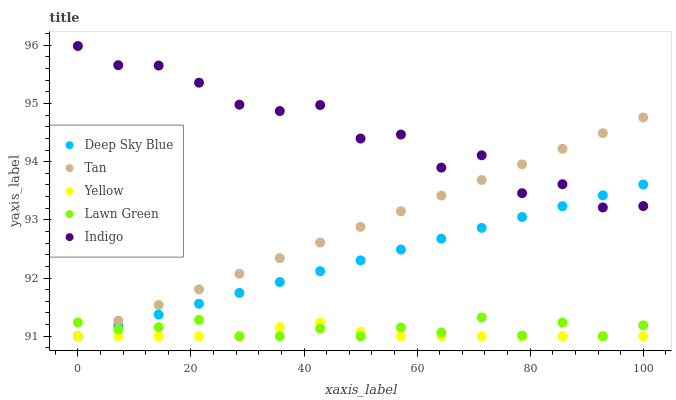Does Yellow have the minimum area under the curve?
Answer yes or no. Yes. Does Indigo have the maximum area under the curve?
Answer yes or no. Yes. Does Tan have the minimum area under the curve?
Answer yes or no. No. Does Tan have the maximum area under the curve?
Answer yes or no. No. Is Tan the smoothest?
Answer yes or no. Yes. Is Indigo the roughest?
Answer yes or no. Yes. Is Indigo the smoothest?
Answer yes or no. No. Is Tan the roughest?
Answer yes or no. No. Does Lawn Green have the lowest value?
Answer yes or no. Yes. Does Indigo have the lowest value?
Answer yes or no. No. Does Indigo have the highest value?
Answer yes or no. Yes. Does Tan have the highest value?
Answer yes or no. No. Is Lawn Green less than Indigo?
Answer yes or no. Yes. Is Indigo greater than Lawn Green?
Answer yes or no. Yes. Does Lawn Green intersect Deep Sky Blue?
Answer yes or no. Yes. Is Lawn Green less than Deep Sky Blue?
Answer yes or no. No. Is Lawn Green greater than Deep Sky Blue?
Answer yes or no. No. Does Lawn Green intersect Indigo?
Answer yes or no. No. 